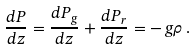Convert formula to latex. <formula><loc_0><loc_0><loc_500><loc_500>\frac { d P } { d z } = \frac { d P _ { g } } { d z } + \frac { d P _ { r } } { d z } = - \, g \rho \, .</formula> 